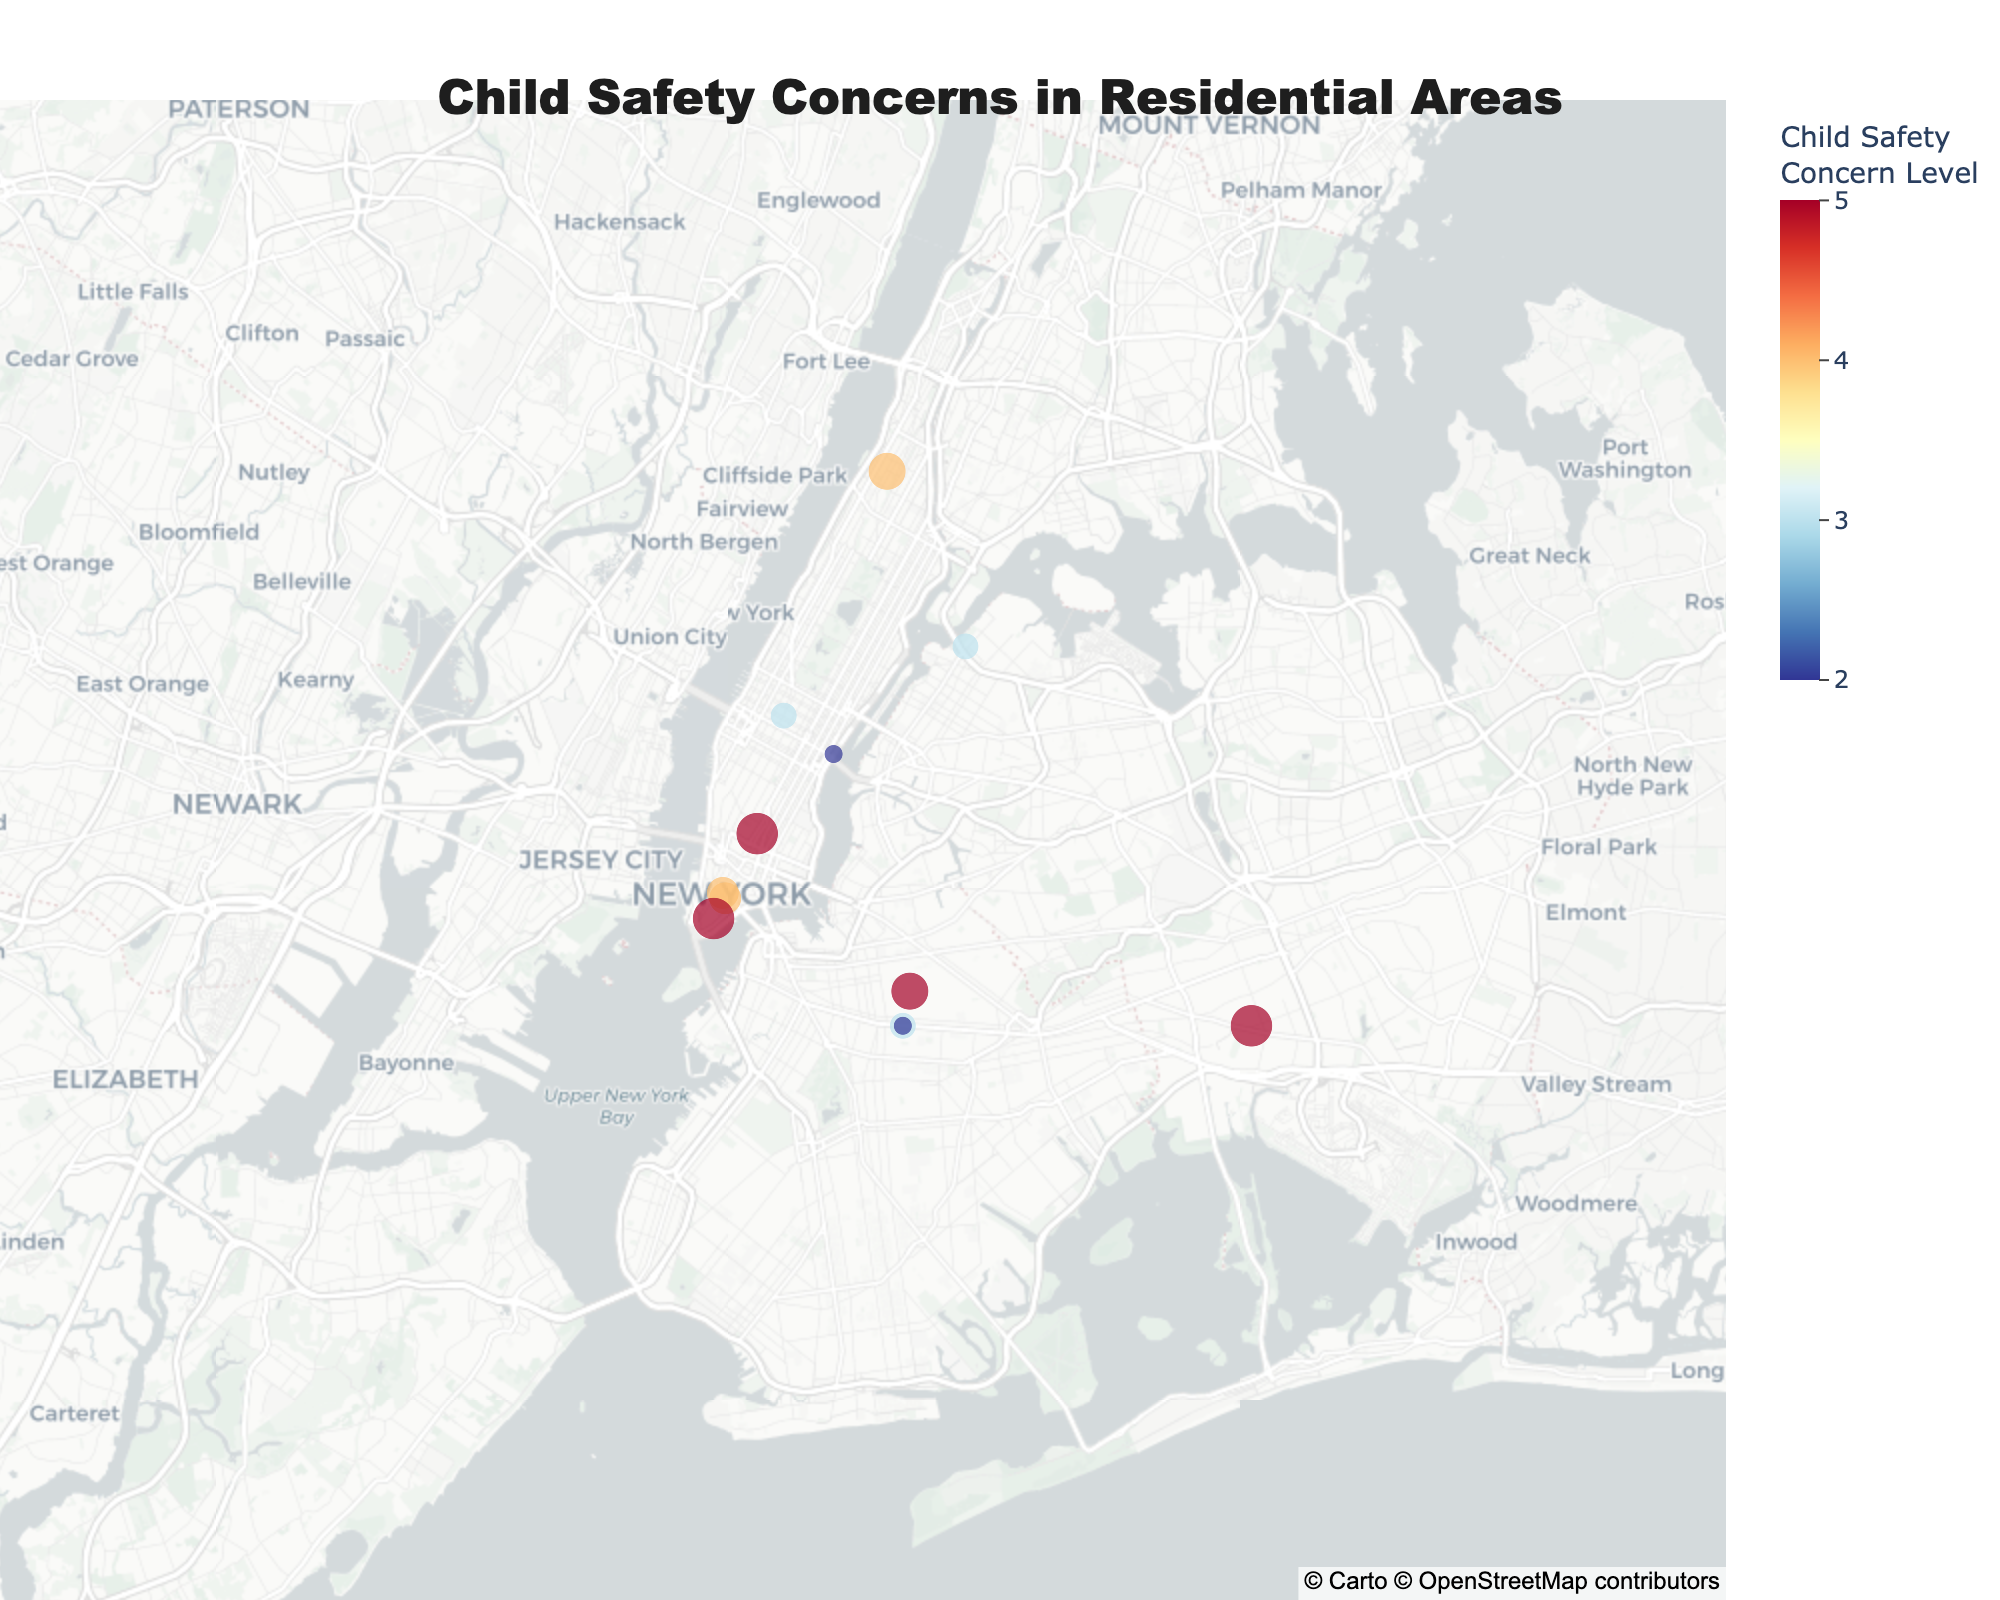How many neighborhoods have a reported child safety concern level of 5? By visually inspecting the color scale and identifying the data points with the darkest color, which represents the highest safety concern level, we can count the number of such incidents.
Answer: 4 Which neighborhood has the lowest severity incident? Find the smallest size of the data points on the map, as the size indicates the severity. Hovering over the smallest point reveals the incident details.
Answer: Midtown What is the incident type reported in Jamaica? Hover over the data point located in Jamaica to view the incident type in the hover data.
Answer: Child Abuse Report Which neighborhood has the highest child safety concern involving "Playground"? From the plot, locate the labels with incident types relating to playgrounds and compare their concern levels.
Answer: Playground Incident in Midtown has a concern level of 2, Playground Equipment Vandalism in Prospect Heights has a concern level of 2 How many incidents are associated with "Kidnapping Attempt"? Look for the data points with "Kidnapping Attempt" in the hover data across the plot and count them.
Answer: 1 Which neighborhoods have reported both child safety concern levels of 4 and a severity of 5? Identify data points with a marked concern level of 4 and then cross-reference these with the severity value of 5.
Answer: Crown Heights, Washington Heights Order the incidents from highest to lowest child safety concern levels. By scanning the color gradients on the heatmap and associating the gradient with the numeric concern level, list the neighborhoods in descending order of concern.
Answer: Jamaica, Crown Heights, Battery Park City, Astoria, Washington Heights, Greenwich Village, Upper East Side, Park Slope, Hell's Kitchen, Long Island City, Prospect Heights, Midtown Which neighborhood has the highest combination of child safety concern level and severity? Multiply the 'Child_Safety_Concern' by 'Severity' for each incident and identify the highest product on the map. The incident in Jamaica has 5 (safety concern) * 5 (severity) = 25.
Answer: Jamaica 